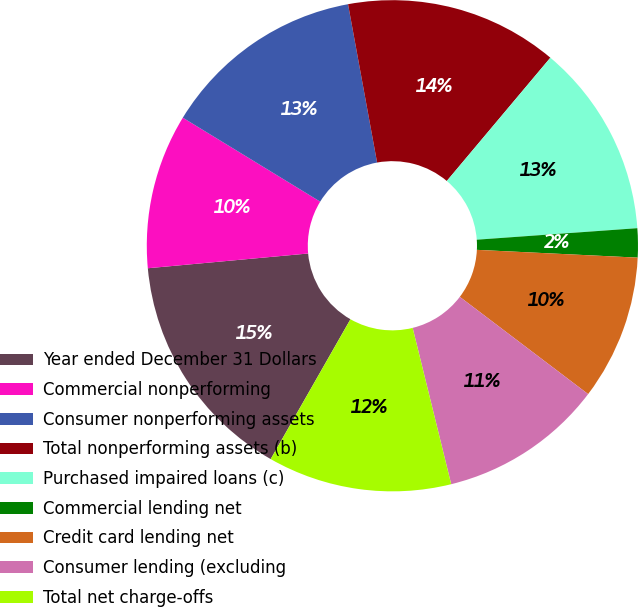<chart> <loc_0><loc_0><loc_500><loc_500><pie_chart><fcel>Year ended December 31 Dollars<fcel>Commercial nonperforming<fcel>Consumer nonperforming assets<fcel>Total nonperforming assets (b)<fcel>Purchased impaired loans (c)<fcel>Commercial lending net<fcel>Credit card lending net<fcel>Consumer lending (excluding<fcel>Total net charge-offs<nl><fcel>15.29%<fcel>10.19%<fcel>13.38%<fcel>14.01%<fcel>12.74%<fcel>1.91%<fcel>9.55%<fcel>10.83%<fcel>12.1%<nl></chart> 